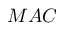<formula> <loc_0><loc_0><loc_500><loc_500>M A C</formula> 